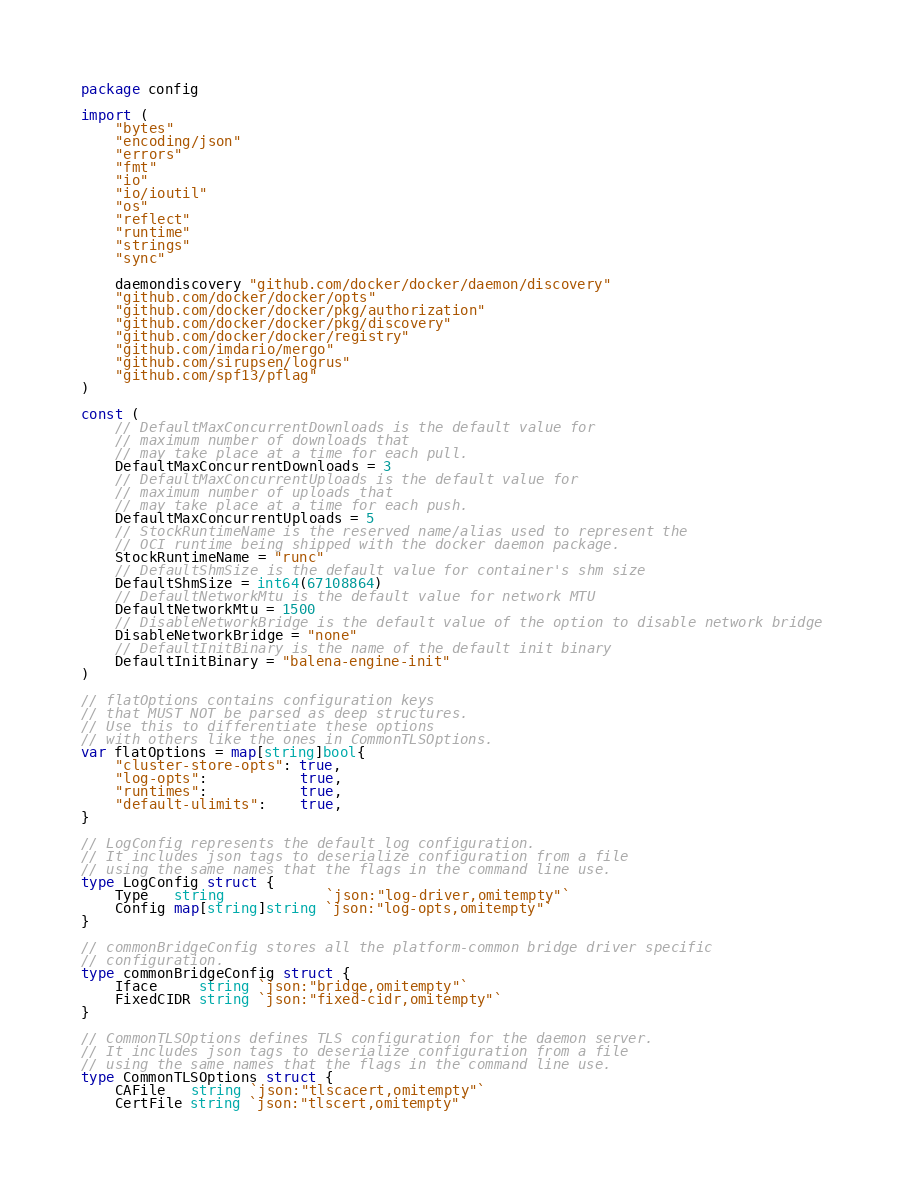Convert code to text. <code><loc_0><loc_0><loc_500><loc_500><_Go_>package config

import (
	"bytes"
	"encoding/json"
	"errors"
	"fmt"
	"io"
	"io/ioutil"
	"os"
	"reflect"
	"runtime"
	"strings"
	"sync"

	daemondiscovery "github.com/docker/docker/daemon/discovery"
	"github.com/docker/docker/opts"
	"github.com/docker/docker/pkg/authorization"
	"github.com/docker/docker/pkg/discovery"
	"github.com/docker/docker/registry"
	"github.com/imdario/mergo"
	"github.com/sirupsen/logrus"
	"github.com/spf13/pflag"
)

const (
	// DefaultMaxConcurrentDownloads is the default value for
	// maximum number of downloads that
	// may take place at a time for each pull.
	DefaultMaxConcurrentDownloads = 3
	// DefaultMaxConcurrentUploads is the default value for
	// maximum number of uploads that
	// may take place at a time for each push.
	DefaultMaxConcurrentUploads = 5
	// StockRuntimeName is the reserved name/alias used to represent the
	// OCI runtime being shipped with the docker daemon package.
	StockRuntimeName = "runc"
	// DefaultShmSize is the default value for container's shm size
	DefaultShmSize = int64(67108864)
	// DefaultNetworkMtu is the default value for network MTU
	DefaultNetworkMtu = 1500
	// DisableNetworkBridge is the default value of the option to disable network bridge
	DisableNetworkBridge = "none"
	// DefaultInitBinary is the name of the default init binary
	DefaultInitBinary = "balena-engine-init"
)

// flatOptions contains configuration keys
// that MUST NOT be parsed as deep structures.
// Use this to differentiate these options
// with others like the ones in CommonTLSOptions.
var flatOptions = map[string]bool{
	"cluster-store-opts": true,
	"log-opts":           true,
	"runtimes":           true,
	"default-ulimits":    true,
}

// LogConfig represents the default log configuration.
// It includes json tags to deserialize configuration from a file
// using the same names that the flags in the command line use.
type LogConfig struct {
	Type   string            `json:"log-driver,omitempty"`
	Config map[string]string `json:"log-opts,omitempty"`
}

// commonBridgeConfig stores all the platform-common bridge driver specific
// configuration.
type commonBridgeConfig struct {
	Iface     string `json:"bridge,omitempty"`
	FixedCIDR string `json:"fixed-cidr,omitempty"`
}

// CommonTLSOptions defines TLS configuration for the daemon server.
// It includes json tags to deserialize configuration from a file
// using the same names that the flags in the command line use.
type CommonTLSOptions struct {
	CAFile   string `json:"tlscacert,omitempty"`
	CertFile string `json:"tlscert,omitempty"`</code> 